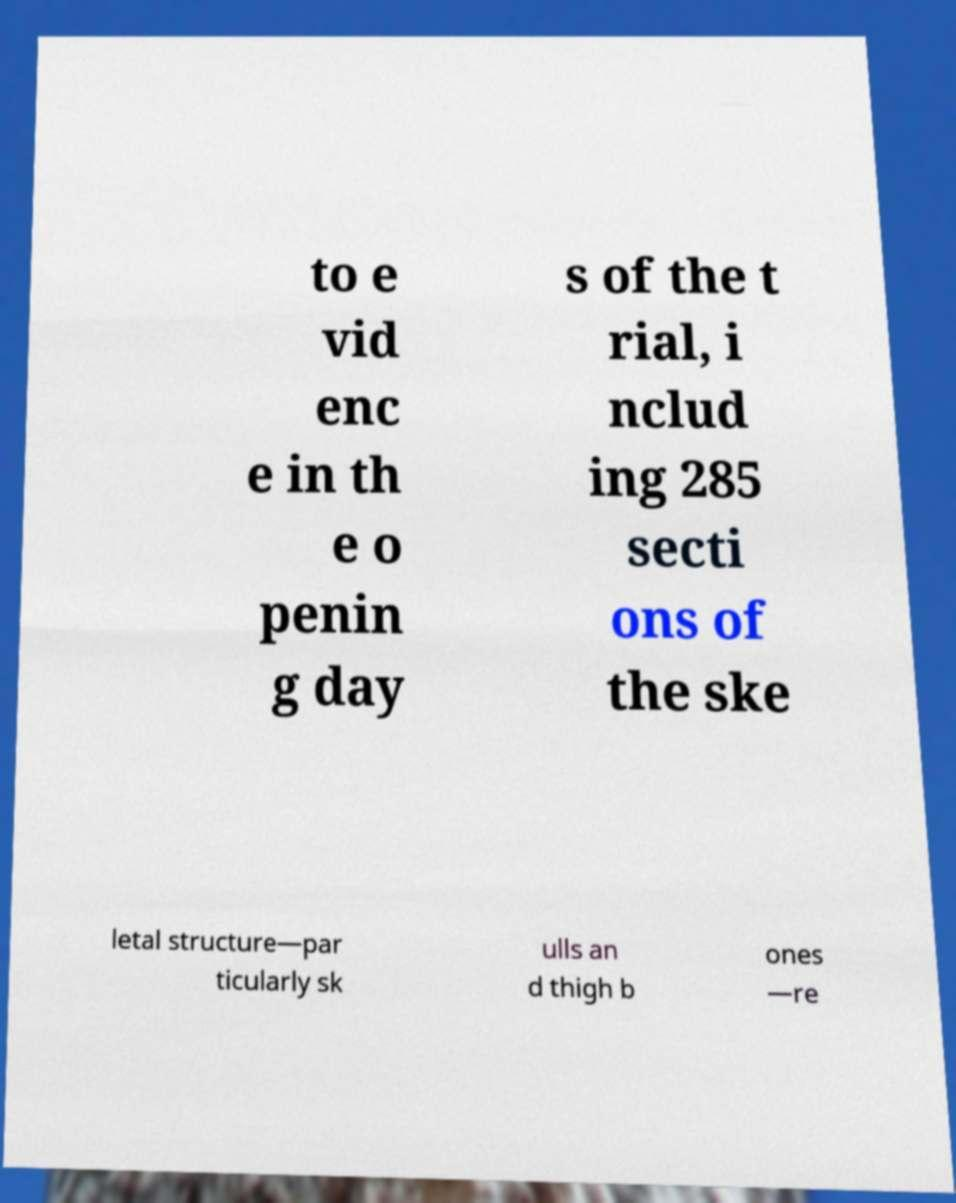For documentation purposes, I need the text within this image transcribed. Could you provide that? to e vid enc e in th e o penin g day s of the t rial, i nclud ing 285 secti ons of the ske letal structure—par ticularly sk ulls an d thigh b ones —re 